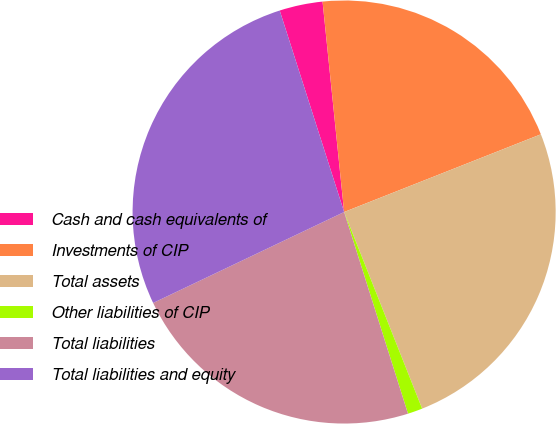<chart> <loc_0><loc_0><loc_500><loc_500><pie_chart><fcel>Cash and cash equivalents of<fcel>Investments of CIP<fcel>Total assets<fcel>Other liabilities of CIP<fcel>Total liabilities<fcel>Total liabilities and equity<nl><fcel>3.3%<fcel>20.64%<fcel>24.98%<fcel>1.13%<fcel>22.81%<fcel>27.15%<nl></chart> 